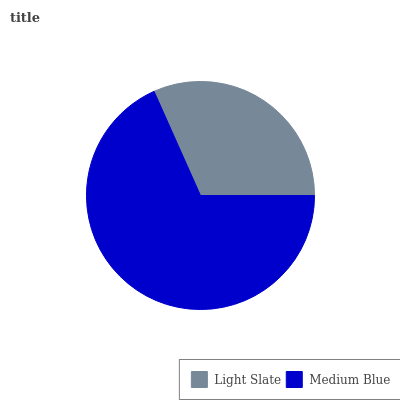Is Light Slate the minimum?
Answer yes or no. Yes. Is Medium Blue the maximum?
Answer yes or no. Yes. Is Medium Blue the minimum?
Answer yes or no. No. Is Medium Blue greater than Light Slate?
Answer yes or no. Yes. Is Light Slate less than Medium Blue?
Answer yes or no. Yes. Is Light Slate greater than Medium Blue?
Answer yes or no. No. Is Medium Blue less than Light Slate?
Answer yes or no. No. Is Medium Blue the high median?
Answer yes or no. Yes. Is Light Slate the low median?
Answer yes or no. Yes. Is Light Slate the high median?
Answer yes or no. No. Is Medium Blue the low median?
Answer yes or no. No. 